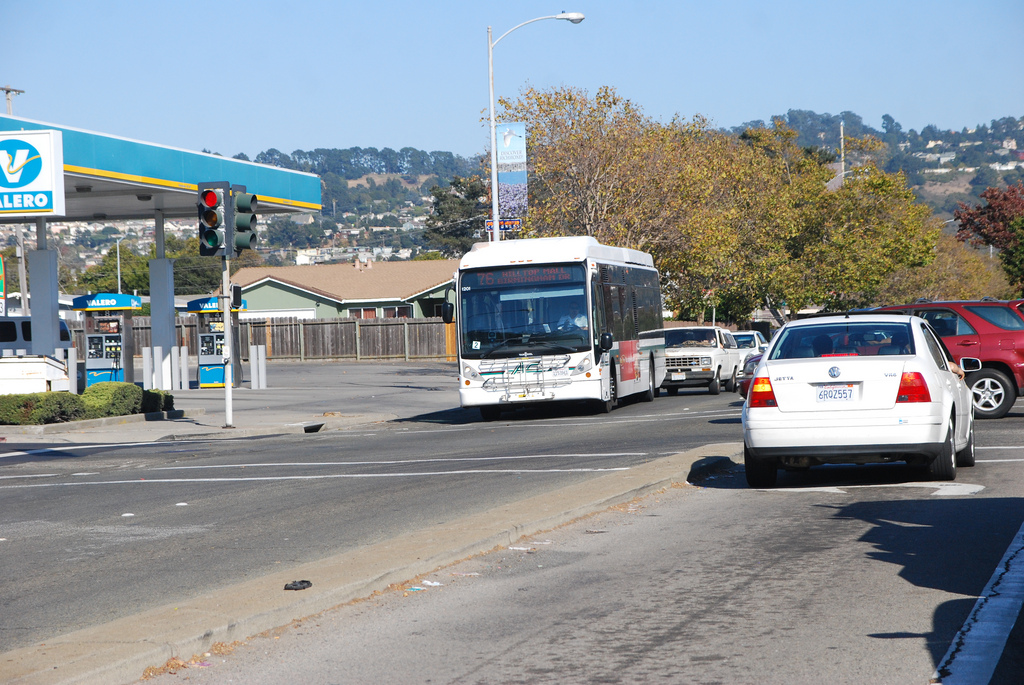What signs of urban infrastructure can be seen in the image? The image shows a road with traffic signals, lane markings, a bus transiting, cars, and a gas station, all typical elements of urban infrastructure. 